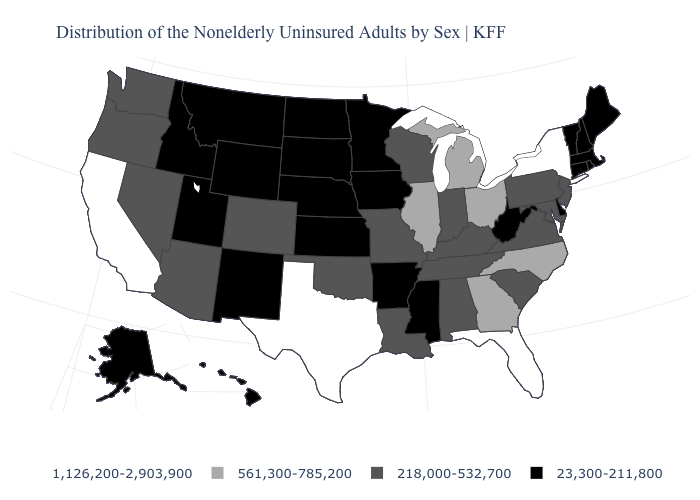Name the states that have a value in the range 218,000-532,700?
Be succinct. Alabama, Arizona, Colorado, Indiana, Kentucky, Louisiana, Maryland, Missouri, Nevada, New Jersey, Oklahoma, Oregon, Pennsylvania, South Carolina, Tennessee, Virginia, Washington, Wisconsin. What is the value of Oklahoma?
Give a very brief answer. 218,000-532,700. Which states have the lowest value in the MidWest?
Write a very short answer. Iowa, Kansas, Minnesota, Nebraska, North Dakota, South Dakota. Does Wisconsin have a lower value than Ohio?
Quick response, please. Yes. What is the value of Iowa?
Answer briefly. 23,300-211,800. How many symbols are there in the legend?
Be succinct. 4. What is the highest value in states that border Missouri?
Give a very brief answer. 561,300-785,200. Among the states that border Louisiana , which have the highest value?
Concise answer only. Texas. Name the states that have a value in the range 1,126,200-2,903,900?
Write a very short answer. California, Florida, New York, Texas. Does Connecticut have the lowest value in the Northeast?
Be succinct. Yes. Which states have the highest value in the USA?
Concise answer only. California, Florida, New York, Texas. Does Kentucky have the lowest value in the South?
Short answer required. No. What is the value of North Dakota?
Be succinct. 23,300-211,800. Does Pennsylvania have the lowest value in the Northeast?
Concise answer only. No. 